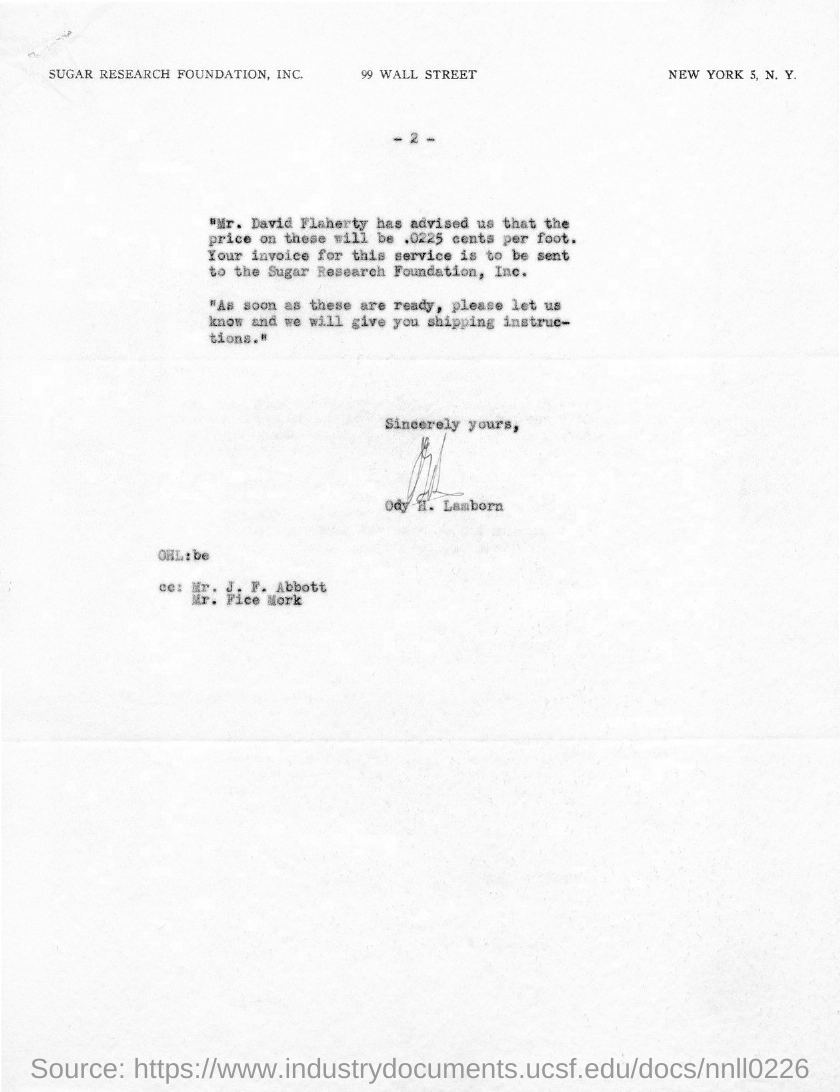What is the page no mentioned in this document?
Offer a very short reply. -2-. Who has signed this letter?
Keep it short and to the point. ODY H. LAMBORN. 